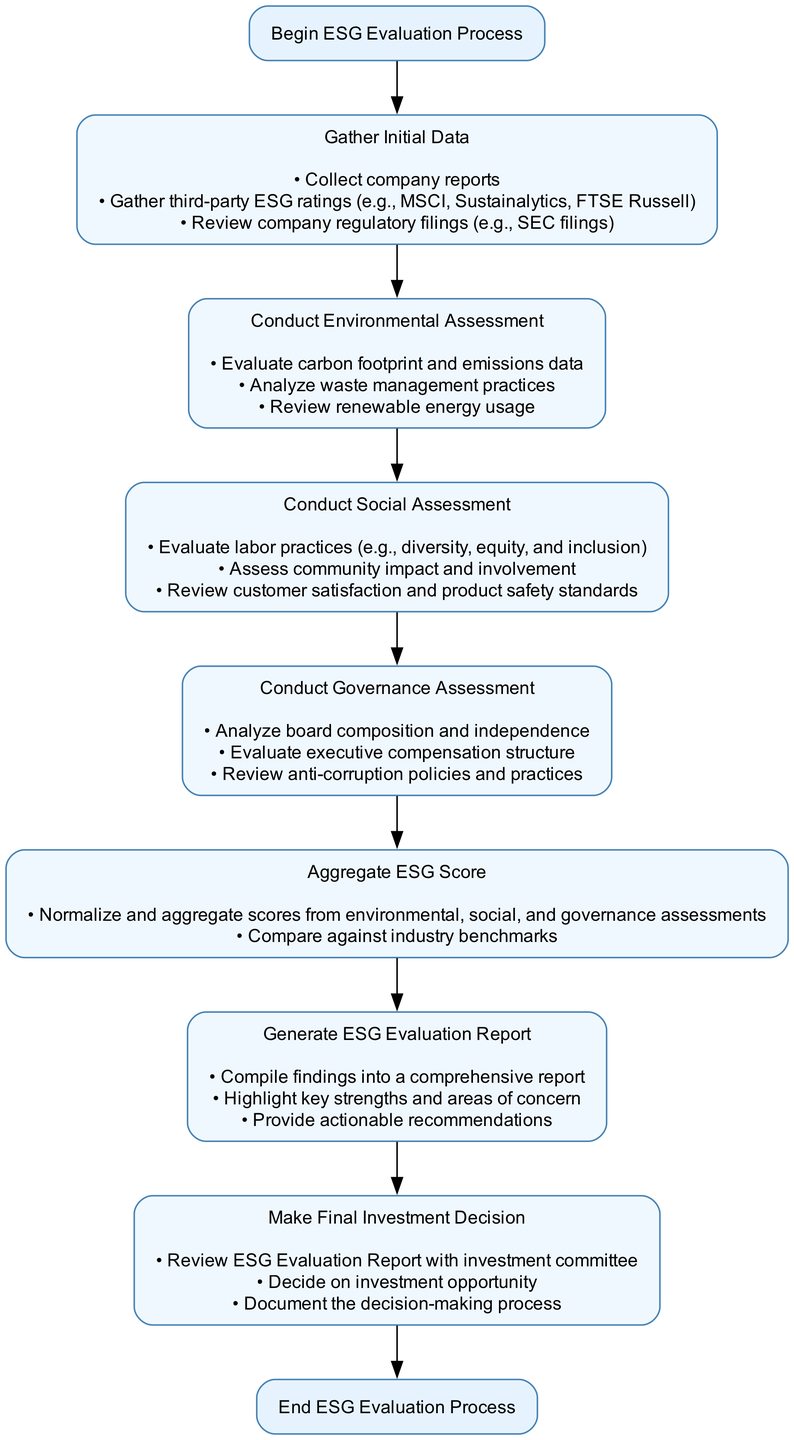What is the first step in the ESG Evaluation Process? The diagram indicates that the first step in the ESG Evaluation Process is to "Gather Initial Data." This is directly stated as the first action in the flowchart.
Answer: Gather Initial Data How many assessment categories are there in the diagram? By examining the diagram, there are three distinct assessment categories present: Environmental, Social, and Governance assessments. Each of these is a key step in the process.
Answer: Three What actions are included in the "Conduct Social Assessment" step? The actions for the "Conduct Social Assessment" step include evaluating labor practices, assessing community impact, and reviewing customer satisfaction and product safety standards. These actions help to detail the social criteria considered.
Answer: Evaluate labor practices, assess community impact, review customer satisfaction and product safety standards Which assessment follows the "Conduct Environmental Assessment"? The flowchart indicates that the assessment that follows the "Conduct Environmental Assessment" is the "Conduct Social Assessment," as they are connected sequentially in the diagram.
Answer: Conduct Social Assessment What is the final step in the ESG Evaluation Process? According to the diagram, the final step in the ESG Evaluation Process is "Make Final Investment Decision," which is indicated as the last action before the end of the process.
Answer: Make Final Investment Decision What are the main actions that occur during the "Aggregate ESG Score" step? The primary actions in the "Aggregate ESG Score" step are to normalize and aggregate scores from the environmental, social, and governance assessments and to compare these scores against industry benchmarks. These actions demonstrate how ESG performance is quantified.
Answer: Normalize and aggregate scores, compare against industry benchmarks How does the ESG Evaluation Process begin and end? The process begins with "Begin ESG Evaluation Process" and ends with "End ESG Evaluation Process." These phrases are clearly specified at the start and end of the diagram, marking the boundaries of the process.
Answer: Begin ESG Evaluation Process and End ESG Evaluation Process What is the purpose of the "Generate ESG Evaluation Report" step? The "Generate ESG Evaluation Report" step compiles findings into a comprehensive report, highlighting key strengths and areas of concern, and provides actionable recommendations, serving as a summary of the evaluation to aid decision-making.
Answer: Compile findings, highlight strengths and areas of concern, provide actionable recommendations Which step includes the review of anti-corruption policies? The review of anti-corruption policies occurs in the "Conduct Governance Assessment" step, as this step focuses on governance factors, including board composition and executive compensation.
Answer: Conduct Governance Assessment 